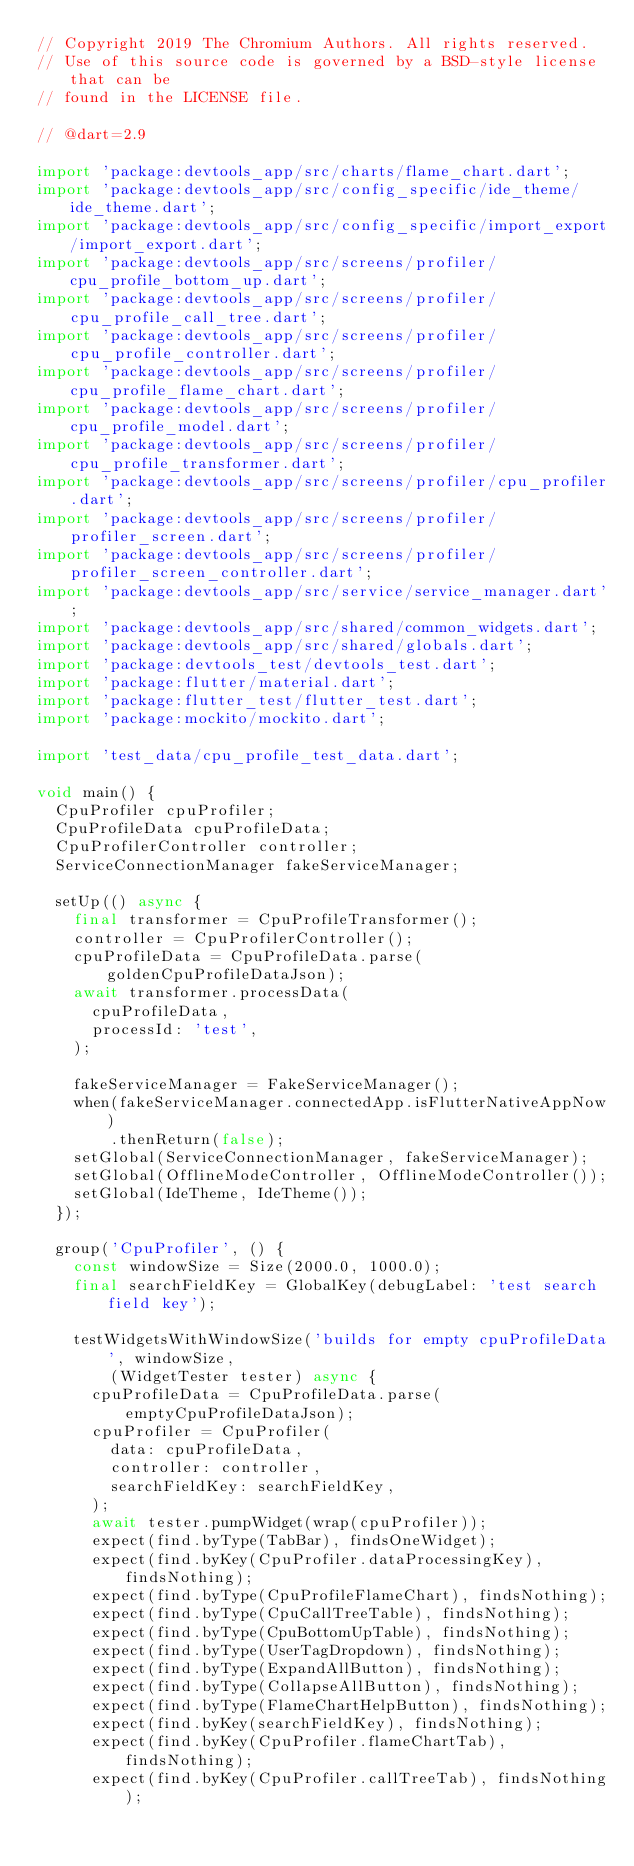Convert code to text. <code><loc_0><loc_0><loc_500><loc_500><_Dart_>// Copyright 2019 The Chromium Authors. All rights reserved.
// Use of this source code is governed by a BSD-style license that can be
// found in the LICENSE file.

// @dart=2.9

import 'package:devtools_app/src/charts/flame_chart.dart';
import 'package:devtools_app/src/config_specific/ide_theme/ide_theme.dart';
import 'package:devtools_app/src/config_specific/import_export/import_export.dart';
import 'package:devtools_app/src/screens/profiler/cpu_profile_bottom_up.dart';
import 'package:devtools_app/src/screens/profiler/cpu_profile_call_tree.dart';
import 'package:devtools_app/src/screens/profiler/cpu_profile_controller.dart';
import 'package:devtools_app/src/screens/profiler/cpu_profile_flame_chart.dart';
import 'package:devtools_app/src/screens/profiler/cpu_profile_model.dart';
import 'package:devtools_app/src/screens/profiler/cpu_profile_transformer.dart';
import 'package:devtools_app/src/screens/profiler/cpu_profiler.dart';
import 'package:devtools_app/src/screens/profiler/profiler_screen.dart';
import 'package:devtools_app/src/screens/profiler/profiler_screen_controller.dart';
import 'package:devtools_app/src/service/service_manager.dart';
import 'package:devtools_app/src/shared/common_widgets.dart';
import 'package:devtools_app/src/shared/globals.dart';
import 'package:devtools_test/devtools_test.dart';
import 'package:flutter/material.dart';
import 'package:flutter_test/flutter_test.dart';
import 'package:mockito/mockito.dart';

import 'test_data/cpu_profile_test_data.dart';

void main() {
  CpuProfiler cpuProfiler;
  CpuProfileData cpuProfileData;
  CpuProfilerController controller;
  ServiceConnectionManager fakeServiceManager;

  setUp(() async {
    final transformer = CpuProfileTransformer();
    controller = CpuProfilerController();
    cpuProfileData = CpuProfileData.parse(goldenCpuProfileDataJson);
    await transformer.processData(
      cpuProfileData,
      processId: 'test',
    );

    fakeServiceManager = FakeServiceManager();
    when(fakeServiceManager.connectedApp.isFlutterNativeAppNow)
        .thenReturn(false);
    setGlobal(ServiceConnectionManager, fakeServiceManager);
    setGlobal(OfflineModeController, OfflineModeController());
    setGlobal(IdeTheme, IdeTheme());
  });

  group('CpuProfiler', () {
    const windowSize = Size(2000.0, 1000.0);
    final searchFieldKey = GlobalKey(debugLabel: 'test search field key');

    testWidgetsWithWindowSize('builds for empty cpuProfileData', windowSize,
        (WidgetTester tester) async {
      cpuProfileData = CpuProfileData.parse(emptyCpuProfileDataJson);
      cpuProfiler = CpuProfiler(
        data: cpuProfileData,
        controller: controller,
        searchFieldKey: searchFieldKey,
      );
      await tester.pumpWidget(wrap(cpuProfiler));
      expect(find.byType(TabBar), findsOneWidget);
      expect(find.byKey(CpuProfiler.dataProcessingKey), findsNothing);
      expect(find.byType(CpuProfileFlameChart), findsNothing);
      expect(find.byType(CpuCallTreeTable), findsNothing);
      expect(find.byType(CpuBottomUpTable), findsNothing);
      expect(find.byType(UserTagDropdown), findsNothing);
      expect(find.byType(ExpandAllButton), findsNothing);
      expect(find.byType(CollapseAllButton), findsNothing);
      expect(find.byType(FlameChartHelpButton), findsNothing);
      expect(find.byKey(searchFieldKey), findsNothing);
      expect(find.byKey(CpuProfiler.flameChartTab), findsNothing);
      expect(find.byKey(CpuProfiler.callTreeTab), findsNothing);</code> 